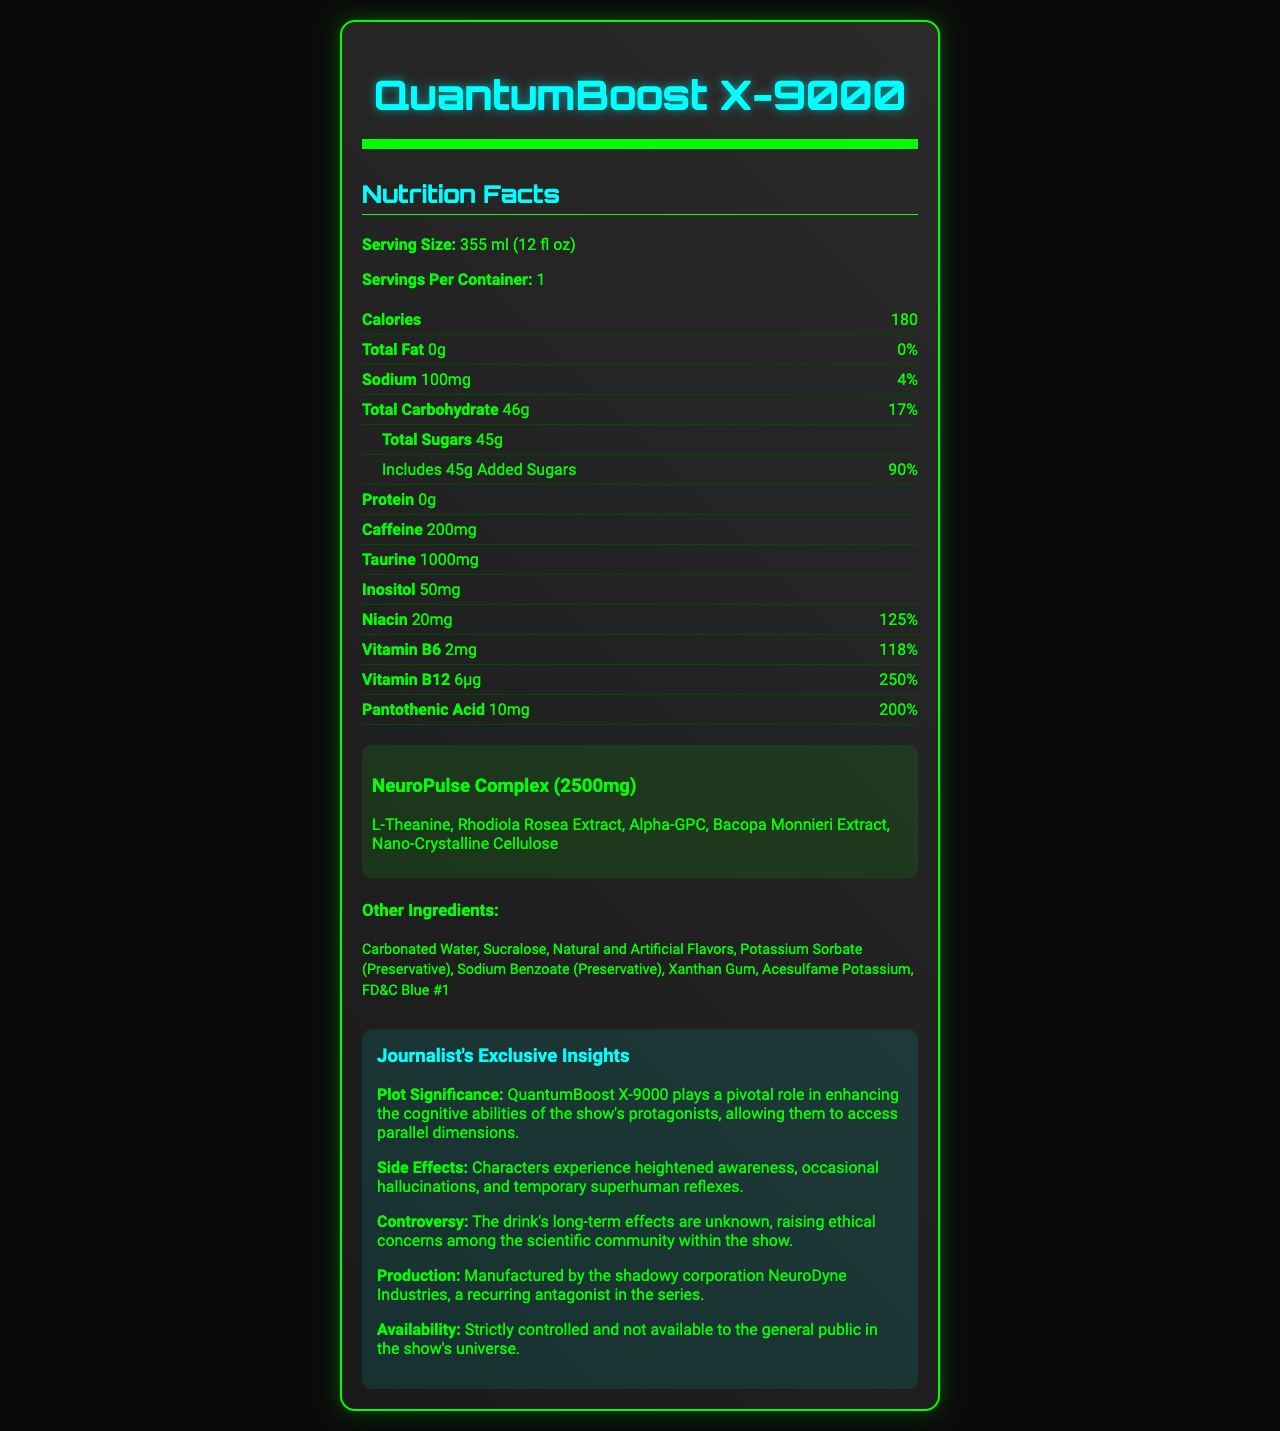what is the product name? The product name is mentioned at the top of the document.
Answer: QuantumBoost X-9000 what is the serving size of QuantumBoost X-9000? This information is found right below the product name in the nutrition facts section.
Answer: 355 ml (12 fl oz) how many calories are in one serving of QuantumBoost X-9000? The calorie count is listed in the nutrition section under "Calories".
Answer: 180 what company manufactures QuantumBoost X-9000? This detail is provided in the "Journalist's Exclusive Insights" section under "Production".
Answer: NeuroDyne Industries what are the key nutrients found in QuantumBoost X-9000’s proprietary blend? The proprietary blend is described in the "NeuroPulse Complex" section.
Answer: L-Theanine, Rhodiola Rosea Extract, Alpha-GPC, Bacopa Monnieri Extract, Nano-Crystalline Cellulose what is the daily value percentage of Vitamin B12 in QuantumBoost X-9000? The percentage daily value of Vitamin B12 is provided next to its amount in the nutrition section.
Answer: 250% how much caffeine does QuantumBoost X-9000 contain per serving? A. 100mg B. 200mg C. 50mg D. 150mg The caffeine content is explicitly listed in the nutrition facts section.
Answer: B. 200mg which vitamin has the highest daily value percentage in QuantumBoost X-9000? A. Niacin B. Vitamin B6 C. Vitamin B12 D. Pantothenic Acid Vitamin B12 has the highest daily value percentage at 250%, followed by Pantothenic Acid at 200%, as detailed in the nutrition facts.
Answer: C. Vitamin B12 is there any fat in QuantumBoost X-9000? The document indicates "Total Fat: 0g", meaning there is no fat.
Answer: No what important role does QuantumBoost X-9000 play in the show's plot? This is described in the "Journalist's Exclusive Insights" section under "Plot Significance".
Answer: It enhances cognitive abilities and allows protagonists to access parallel dimensions. what are the possible side effects of consuming QuantumBoost X-9000? These side effects are mentioned in the "Journalist's Exclusive Insights" section under "Side Effects".
Answer: Heightened awareness, hallucinations, temporary superhuman reflexes how much total carbohydrate is in one serving? The total carbohydrate content is listed in the nutrition facts section.
Answer: 46g what color dye is used in QuantumBoost X-9000? This is mentioned in the "Other Ingredients" section.
Answer: FD&C Blue #1 what long-term concerns are raised about QuantumBoost X-9000? This is explained in the "Journalist's Exclusive Insights" section under "Controversy".
Answer: The long-term effects are unknown, raising ethical concerns among the scientific community. summarize the main idea of the QuantumBoost X-9000 nutrition facts document. The overall document provides detailed nutritional information, proprietary ingredients, and exclusive insights into the plot significance and potential side effects relevant to the TV series.
Answer: QuantumBoost X-9000 is an energy drink with a unique blend of nutrients and a proprietary blend designed to enhance cognitive abilities. It is high in sugars and artificial ingredients and is pivotal to the plot of a sci-fi show. The drink offers short-term benefits like heightened awareness and reflexes but raises long-term ethical concerns within the show’s narrative. what flavor is QuantumBoost X-9000? The document does not provide any information regarding the flavor of the drink.
Answer: Not enough information 